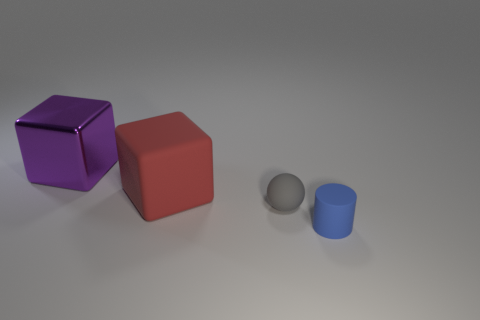Can you describe the texture and size relationships among the objects? Certainly! In the image, there is a large purple metallic cube that has a shiny, reflective surface. Next to it is a large, matte red cube with a non-reflective surface, appearing slightly less vibrant. Both cubes are roughly the same size. To the right, there is a small red rubber cube with a slightly textured, less shiny surface and a small blue cylinder that has a matte, smooth finish. The rubber cube and the cylinder are both much smaller compared to the two large cubes. 